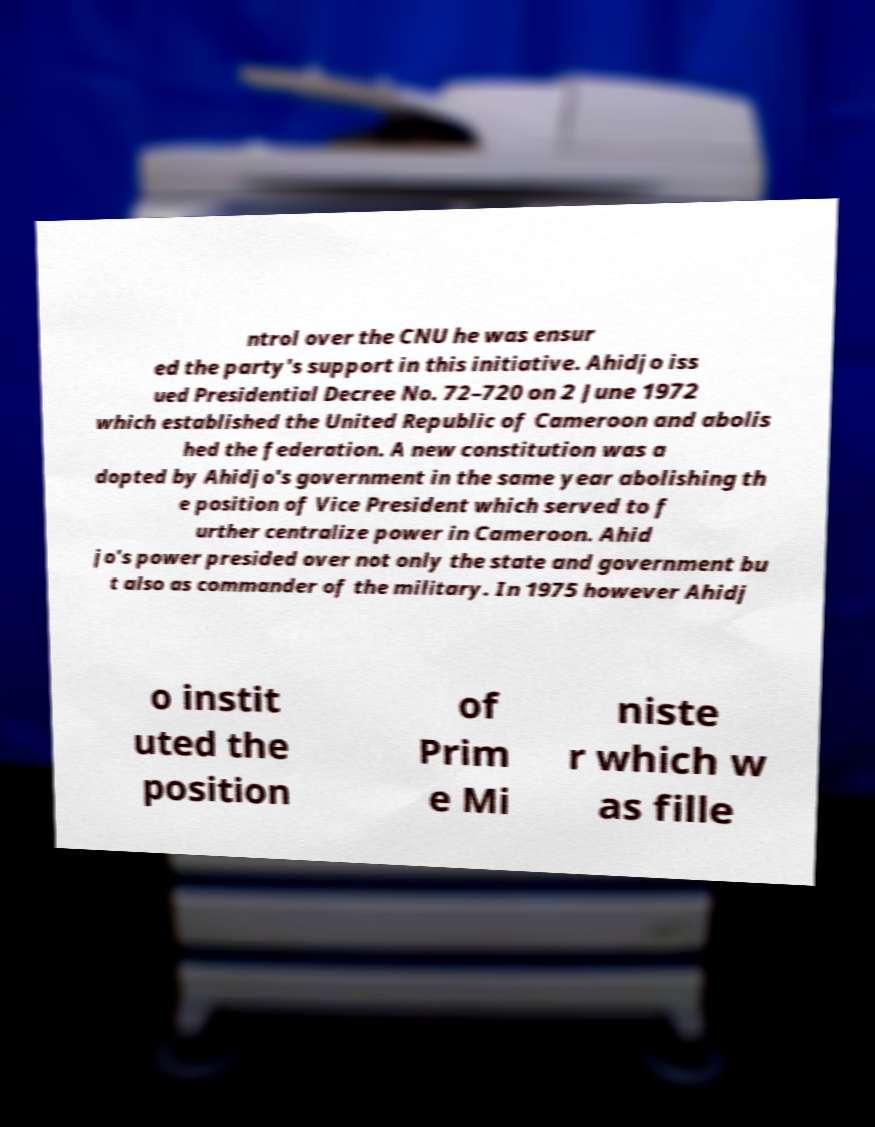Can you read and provide the text displayed in the image?This photo seems to have some interesting text. Can you extract and type it out for me? ntrol over the CNU he was ensur ed the party's support in this initiative. Ahidjo iss ued Presidential Decree No. 72–720 on 2 June 1972 which established the United Republic of Cameroon and abolis hed the federation. A new constitution was a dopted by Ahidjo's government in the same year abolishing th e position of Vice President which served to f urther centralize power in Cameroon. Ahid jo's power presided over not only the state and government bu t also as commander of the military. In 1975 however Ahidj o instit uted the position of Prim e Mi niste r which w as fille 